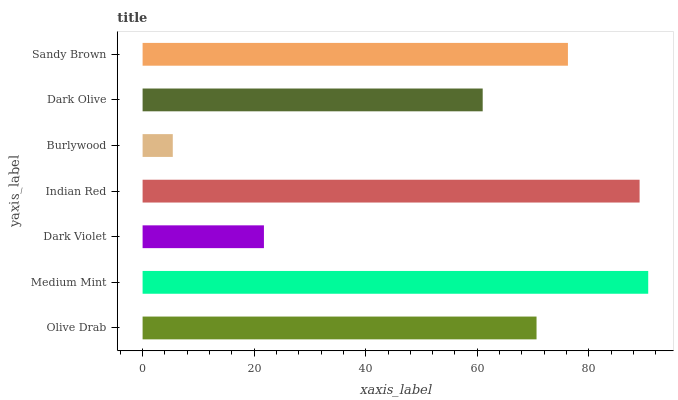Is Burlywood the minimum?
Answer yes or no. Yes. Is Medium Mint the maximum?
Answer yes or no. Yes. Is Dark Violet the minimum?
Answer yes or no. No. Is Dark Violet the maximum?
Answer yes or no. No. Is Medium Mint greater than Dark Violet?
Answer yes or no. Yes. Is Dark Violet less than Medium Mint?
Answer yes or no. Yes. Is Dark Violet greater than Medium Mint?
Answer yes or no. No. Is Medium Mint less than Dark Violet?
Answer yes or no. No. Is Olive Drab the high median?
Answer yes or no. Yes. Is Olive Drab the low median?
Answer yes or no. Yes. Is Burlywood the high median?
Answer yes or no. No. Is Dark Violet the low median?
Answer yes or no. No. 